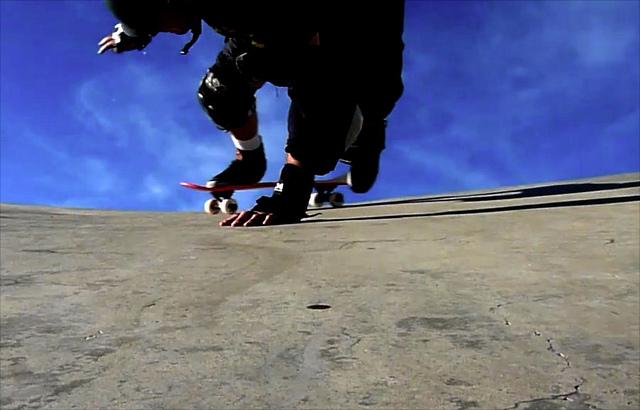What is the man bracing himself with?
Concise answer only. Hand. Are there cracks in the surface?
Concise answer only. Yes. What is this man riding?
Give a very brief answer. Skateboard. 